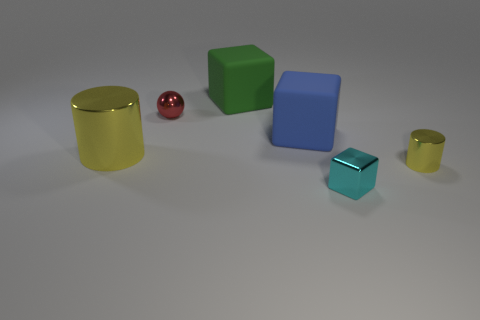Add 1 tiny purple matte things. How many objects exist? 7 Subtract all cylinders. How many objects are left? 4 Add 3 large yellow objects. How many large yellow objects exist? 4 Subtract 0 cyan spheres. How many objects are left? 6 Subtract all cyan things. Subtract all small green shiny cylinders. How many objects are left? 5 Add 4 green things. How many green things are left? 5 